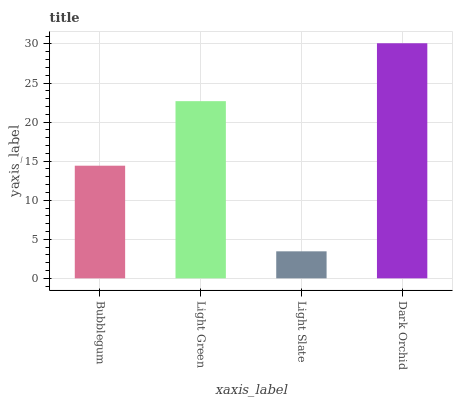Is Light Slate the minimum?
Answer yes or no. Yes. Is Dark Orchid the maximum?
Answer yes or no. Yes. Is Light Green the minimum?
Answer yes or no. No. Is Light Green the maximum?
Answer yes or no. No. Is Light Green greater than Bubblegum?
Answer yes or no. Yes. Is Bubblegum less than Light Green?
Answer yes or no. Yes. Is Bubblegum greater than Light Green?
Answer yes or no. No. Is Light Green less than Bubblegum?
Answer yes or no. No. Is Light Green the high median?
Answer yes or no. Yes. Is Bubblegum the low median?
Answer yes or no. Yes. Is Bubblegum the high median?
Answer yes or no. No. Is Light Green the low median?
Answer yes or no. No. 